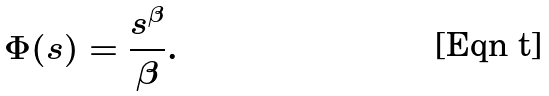Convert formula to latex. <formula><loc_0><loc_0><loc_500><loc_500>\Phi ( s ) = \frac { s ^ { \beta } } { \beta } .</formula> 